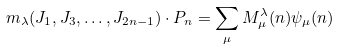Convert formula to latex. <formula><loc_0><loc_0><loc_500><loc_500>m _ { \lambda } ( J _ { 1 } , J _ { 3 } , \dots , J _ { 2 n - 1 } ) \cdot P _ { n } = \sum _ { \mu } M ^ { \lambda } _ { \mu } ( n ) \psi _ { \mu } ( n )</formula> 